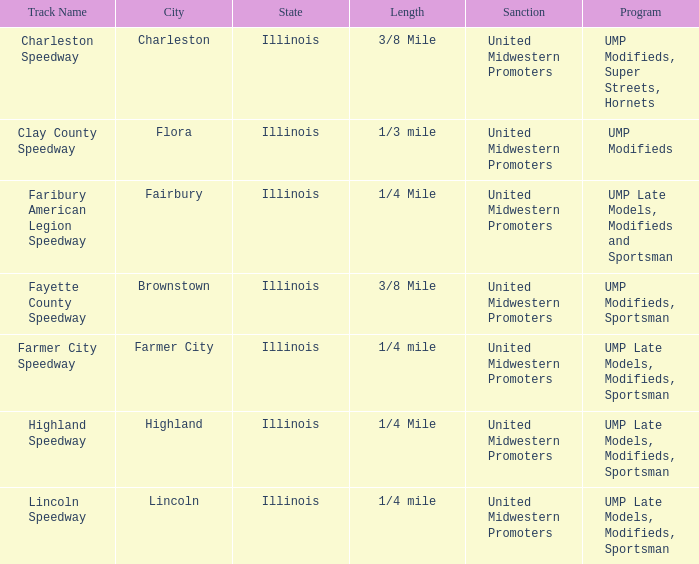What place is farmer city speedway? Farmer City, Illinois. 